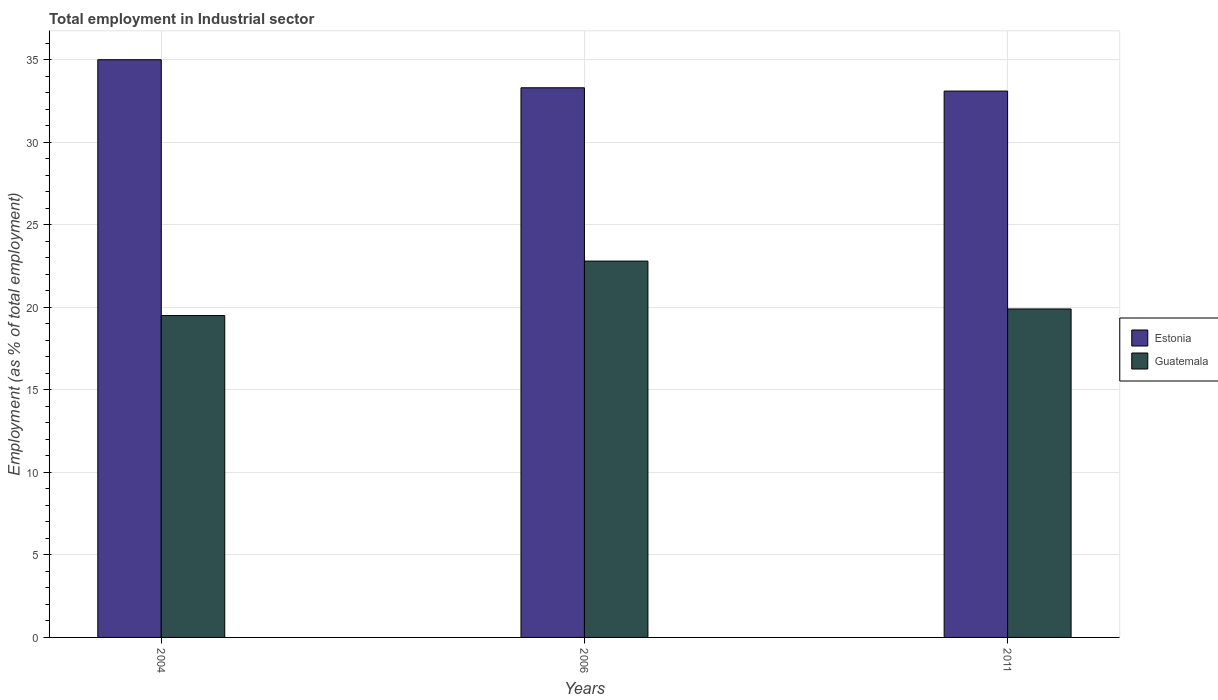How many groups of bars are there?
Provide a short and direct response. 3. What is the label of the 1st group of bars from the left?
Ensure brevity in your answer.  2004. What is the employment in industrial sector in Estonia in 2006?
Provide a succinct answer. 33.3. Across all years, what is the maximum employment in industrial sector in Estonia?
Offer a terse response. 35. Across all years, what is the minimum employment in industrial sector in Estonia?
Your response must be concise. 33.1. In which year was the employment in industrial sector in Guatemala maximum?
Your response must be concise. 2006. What is the total employment in industrial sector in Guatemala in the graph?
Offer a terse response. 62.2. What is the difference between the employment in industrial sector in Estonia in 2004 and that in 2011?
Your answer should be compact. 1.9. What is the difference between the employment in industrial sector in Guatemala in 2011 and the employment in industrial sector in Estonia in 2004?
Your response must be concise. -15.1. What is the average employment in industrial sector in Guatemala per year?
Offer a terse response. 20.73. In the year 2006, what is the difference between the employment in industrial sector in Estonia and employment in industrial sector in Guatemala?
Offer a terse response. 10.5. In how many years, is the employment in industrial sector in Guatemala greater than 34 %?
Offer a terse response. 0. What is the ratio of the employment in industrial sector in Estonia in 2006 to that in 2011?
Keep it short and to the point. 1.01. Is the employment in industrial sector in Guatemala in 2004 less than that in 2006?
Ensure brevity in your answer.  Yes. Is the difference between the employment in industrial sector in Estonia in 2004 and 2006 greater than the difference between the employment in industrial sector in Guatemala in 2004 and 2006?
Your answer should be very brief. Yes. What is the difference between the highest and the second highest employment in industrial sector in Estonia?
Keep it short and to the point. 1.7. What is the difference between the highest and the lowest employment in industrial sector in Estonia?
Offer a very short reply. 1.9. Is the sum of the employment in industrial sector in Guatemala in 2004 and 2006 greater than the maximum employment in industrial sector in Estonia across all years?
Provide a short and direct response. Yes. What does the 1st bar from the left in 2004 represents?
Your response must be concise. Estonia. What does the 1st bar from the right in 2006 represents?
Provide a succinct answer. Guatemala. Are all the bars in the graph horizontal?
Ensure brevity in your answer.  No. How many years are there in the graph?
Your answer should be very brief. 3. Are the values on the major ticks of Y-axis written in scientific E-notation?
Offer a terse response. No. Does the graph contain any zero values?
Your answer should be very brief. No. Does the graph contain grids?
Your answer should be very brief. Yes. How are the legend labels stacked?
Offer a terse response. Vertical. What is the title of the graph?
Provide a succinct answer. Total employment in Industrial sector. Does "Albania" appear as one of the legend labels in the graph?
Give a very brief answer. No. What is the label or title of the Y-axis?
Offer a terse response. Employment (as % of total employment). What is the Employment (as % of total employment) in Estonia in 2006?
Make the answer very short. 33.3. What is the Employment (as % of total employment) of Guatemala in 2006?
Offer a very short reply. 22.8. What is the Employment (as % of total employment) in Estonia in 2011?
Make the answer very short. 33.1. What is the Employment (as % of total employment) of Guatemala in 2011?
Offer a terse response. 19.9. Across all years, what is the maximum Employment (as % of total employment) of Estonia?
Provide a succinct answer. 35. Across all years, what is the maximum Employment (as % of total employment) in Guatemala?
Provide a short and direct response. 22.8. Across all years, what is the minimum Employment (as % of total employment) in Estonia?
Offer a terse response. 33.1. What is the total Employment (as % of total employment) in Estonia in the graph?
Ensure brevity in your answer.  101.4. What is the total Employment (as % of total employment) in Guatemala in the graph?
Provide a succinct answer. 62.2. What is the difference between the Employment (as % of total employment) of Guatemala in 2004 and that in 2006?
Offer a very short reply. -3.3. What is the difference between the Employment (as % of total employment) of Estonia in 2006 and that in 2011?
Your response must be concise. 0.2. What is the difference between the Employment (as % of total employment) of Guatemala in 2006 and that in 2011?
Provide a succinct answer. 2.9. What is the difference between the Employment (as % of total employment) in Estonia in 2004 and the Employment (as % of total employment) in Guatemala in 2006?
Your response must be concise. 12.2. What is the average Employment (as % of total employment) of Estonia per year?
Ensure brevity in your answer.  33.8. What is the average Employment (as % of total employment) of Guatemala per year?
Your answer should be compact. 20.73. In the year 2004, what is the difference between the Employment (as % of total employment) in Estonia and Employment (as % of total employment) in Guatemala?
Your response must be concise. 15.5. What is the ratio of the Employment (as % of total employment) of Estonia in 2004 to that in 2006?
Make the answer very short. 1.05. What is the ratio of the Employment (as % of total employment) in Guatemala in 2004 to that in 2006?
Your response must be concise. 0.86. What is the ratio of the Employment (as % of total employment) in Estonia in 2004 to that in 2011?
Provide a succinct answer. 1.06. What is the ratio of the Employment (as % of total employment) of Guatemala in 2004 to that in 2011?
Offer a terse response. 0.98. What is the ratio of the Employment (as % of total employment) in Guatemala in 2006 to that in 2011?
Your response must be concise. 1.15. What is the difference between the highest and the second highest Employment (as % of total employment) of Estonia?
Your answer should be compact. 1.7. What is the difference between the highest and the second highest Employment (as % of total employment) in Guatemala?
Keep it short and to the point. 2.9. What is the difference between the highest and the lowest Employment (as % of total employment) in Estonia?
Provide a succinct answer. 1.9. What is the difference between the highest and the lowest Employment (as % of total employment) of Guatemala?
Give a very brief answer. 3.3. 